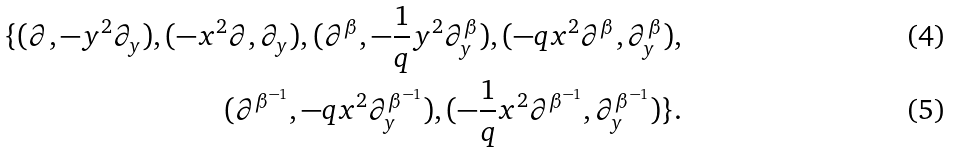<formula> <loc_0><loc_0><loc_500><loc_500>\{ ( \partial , - y ^ { 2 } \partial _ { y } ) , ( - x ^ { 2 } \partial , \partial _ { y } ) , ( \partial ^ { \beta } , - \frac { 1 } { q } y ^ { 2 } \partial _ { y } ^ { \beta } ) , ( - q x ^ { 2 } \partial ^ { \beta } , \partial _ { y } ^ { \beta } ) , \\ ( \partial ^ { \beta ^ { - 1 } } , - q x ^ { 2 } \partial _ { y } ^ { \beta ^ { - 1 } } ) , ( - \frac { 1 } { q } x ^ { 2 } \partial ^ { \beta ^ { - 1 } } , \partial _ { y } ^ { \beta ^ { - 1 } } ) \} .</formula> 